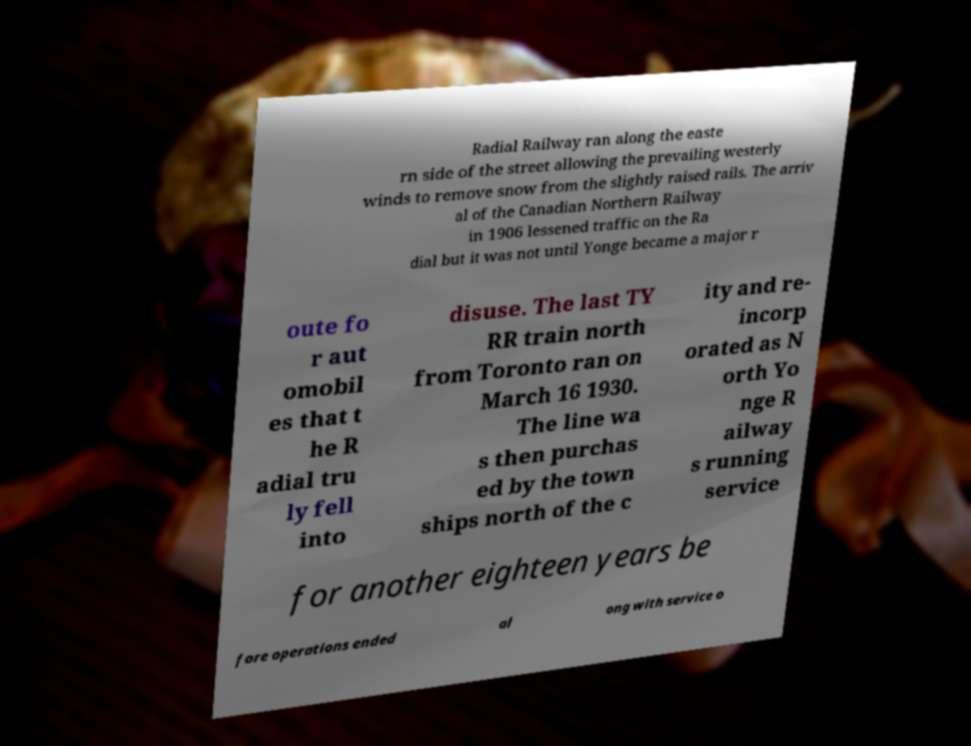Could you extract and type out the text from this image? Radial Railway ran along the easte rn side of the street allowing the prevailing westerly winds to remove snow from the slightly raised rails. The arriv al of the Canadian Northern Railway in 1906 lessened traffic on the Ra dial but it was not until Yonge became a major r oute fo r aut omobil es that t he R adial tru ly fell into disuse. The last TY RR train north from Toronto ran on March 16 1930. The line wa s then purchas ed by the town ships north of the c ity and re- incorp orated as N orth Yo nge R ailway s running service for another eighteen years be fore operations ended al ong with service o 